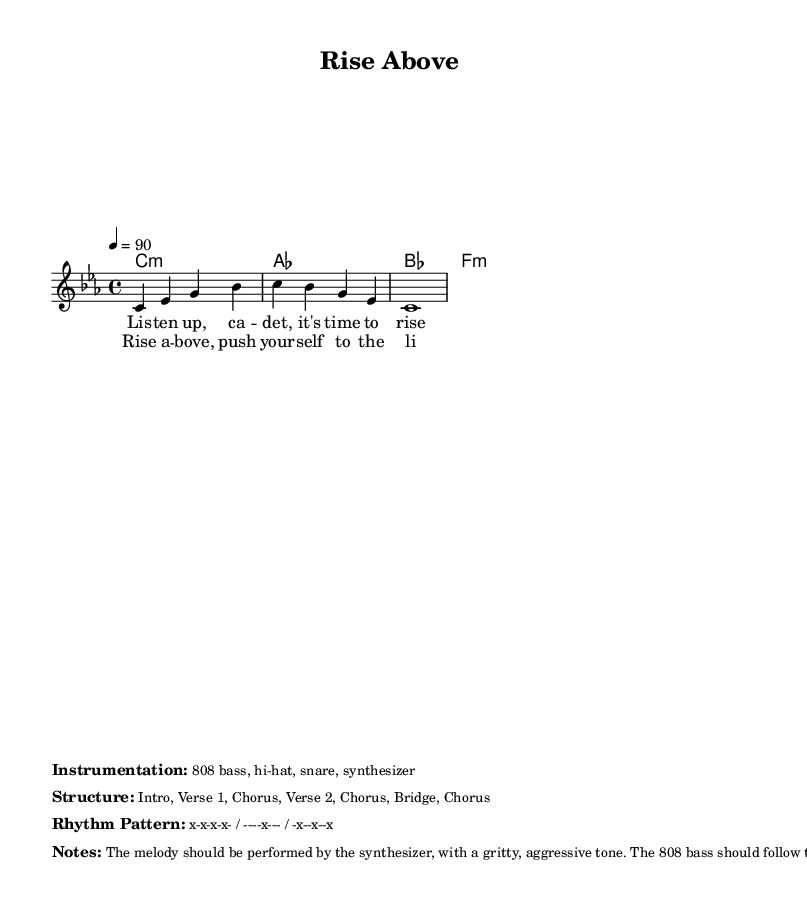What is the key signature of this music? The key signature is C minor, which is indicated by three flats.
Answer: C minor What is the time signature of the piece? The time signature shown is 4/4, meaning there are four beats in each measure.
Answer: 4/4 What is the tempo marking? The tempo marking is 4 = 90, indicating the beats per minute.
Answer: 90 How many verses are in the structure of the song? The structure includes two verses as noted in the layout description.
Answer: Two What type of instrumentation does this piece use? The instrumentation includes 808 bass, hi-hat, snare, and synthesizer, which are all typical for rap.
Answer: 808 bass, hi-hat, snare, synthesizer What is the primary theme of the rap lyrics? The lyrics focus on rising above challenges and pushing oneself to limits, which is a motivational theme common in rap.
Answer: Overcoming challenges 